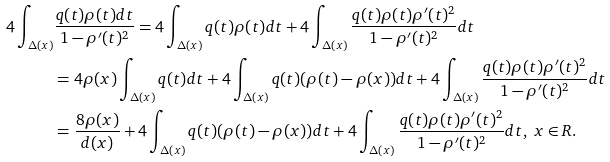Convert formula to latex. <formula><loc_0><loc_0><loc_500><loc_500>4 \int _ { \Delta ( x ) } & \frac { q ( t ) \rho ( t ) d t } { 1 - \rho ^ { \prime } ( t ) ^ { 2 } } = 4 \int _ { \Delta ( x ) } q ( t ) \rho ( t ) d t + 4 \int _ { \Delta ( x ) } \frac { q ( t ) \rho ( t ) \rho ^ { \prime } ( t ) ^ { 2 } } { 1 - \rho ^ { \prime } ( t ) ^ { 2 } } d t \\ & = 4 \rho ( x ) \int _ { \Delta ( x ) } q ( t ) d t + 4 \int _ { \Delta ( x ) } q ( t ) ( \rho ( t ) - \rho ( x ) ) d t + 4 \int _ { \Delta ( x ) } \frac { q ( t ) \rho ( t ) \rho ^ { \prime } ( t ) ^ { 2 } } { 1 - \rho ^ { \prime } ( t ) ^ { 2 } } d t \\ & = \frac { 8 \rho ( x ) } { d ( x ) } + 4 \int _ { \Delta ( x ) } q ( t ) ( \rho ( t ) - \rho ( x ) ) d t + 4 \int _ { \Delta ( x ) } \frac { q ( t ) \rho ( t ) \rho ^ { \prime } ( t ) ^ { 2 } } { 1 - \rho ^ { \prime } ( t ) ^ { 2 } } d t , \ x \in R .</formula> 